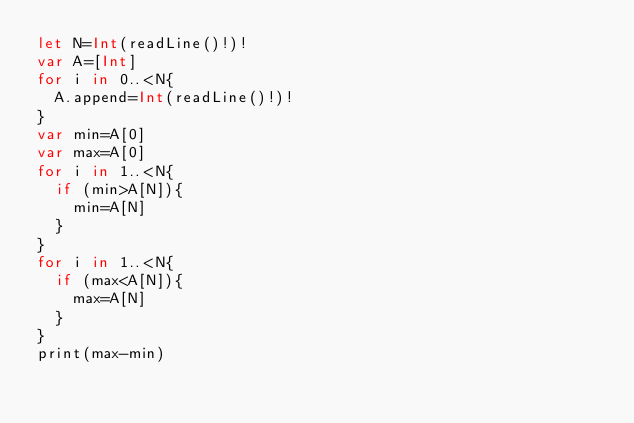<code> <loc_0><loc_0><loc_500><loc_500><_Swift_>let N=Int(readLine()!)!
var A=[Int]
for i in 0..<N{
  A.append=Int(readLine()!)!
}
var min=A[0]
var max=A[0]
for i in 1..<N{
  if (min>A[N]){
    min=A[N]
  }
}
for i in 1..<N{
  if (max<A[N]){
    max=A[N]
  }
}
print(max-min)</code> 